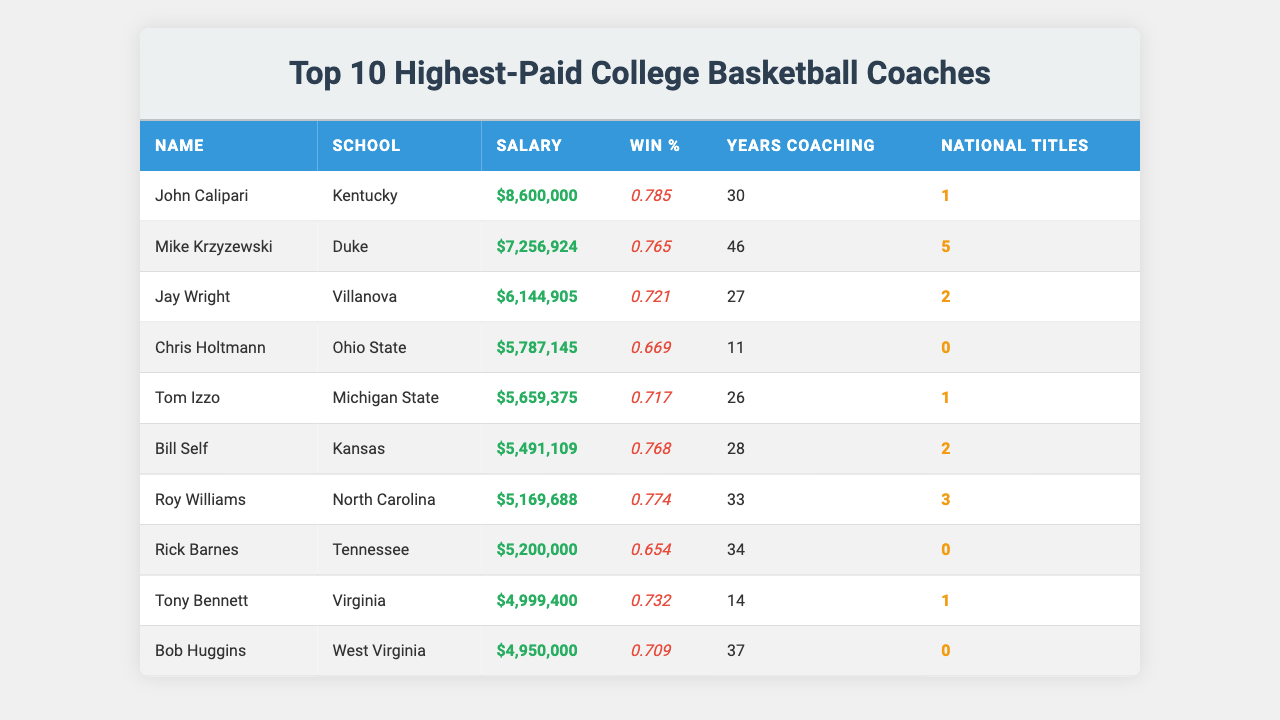What is the salary of John Calipari? In the table, John Calipari's salary is listed in the "Salary" column. It shows $8,600,000.
Answer: $8,600,000 Which coach has the highest win percentage? By examining the "Win %" column, John Calipari has the highest win percentage at 0.785 compared to other coaches.
Answer: John Calipari How many national titles has Mike Krzyzewski won? The "National Titles" column next to Mike Krzyzewski shows that he has won 5 national titles.
Answer: 5 What is the average salary of the top 10 coaches? First, add all the salaries: 8,600,000 + 7,256,924 + 6,144,905 + 5,787,145 + 5,659,375 + 5,491,109 + 5,169,688 + 5,200,000 + 4,999,400 + 4,950,000 = 59,260,646. Then divide by 10 for the average: 59,260,646 / 10 = 5,926,064.6.
Answer: $5,926,064.60 Which coach has the longest coaching career and what is their win percentage? Bob Huggins has the longest coaching career with 37 years, and his win percentage is 0.709, found in the respective columns.
Answer: Bob Huggins, 0.709 What is the difference in win percentage between Tom Izzo and Chris Holtmann? Tom Izzo has a win percentage of 0.717, and Chris Holtmann has 0.669. The difference is 0.717 - 0.669 = 0.048.
Answer: 0.048 Is it true that all coaches listed have at least one national title? By reviewing the "National Titles" column, Chris Holtmann and Rick Barnes have 0 national titles. Therefore, the statement is false.
Answer: No Which coach has a higher salary, Roy Williams or Tony Bennett? Roy Williams has a salary of $5,169,688, while Tony Bennett has a salary of $4,999,400. Comparing these amounts shows that Roy Williams has a higher salary.
Answer: Roy Williams How many coaches have a win percentage above 0.75? Reviewing the "Win %" column, only John Calipari (0.785) and Roy Williams (0.774) have a win percentage above 0.75.
Answer: 2 What is the total number of national titles among the top 10 coaches? Adding the national titles: 1 + 5 + 2 + 0 + 1 + 2 + 3 + 0 + 1 + 0 = 15 total national titles among all coaches.
Answer: 15 Who is the coach with the lowest win percentage and what is that percentage? Chris Holtmann has the lowest win percentage at 0.669 according to the "Win %" column.
Answer: Chris Holtmann, 0.669 